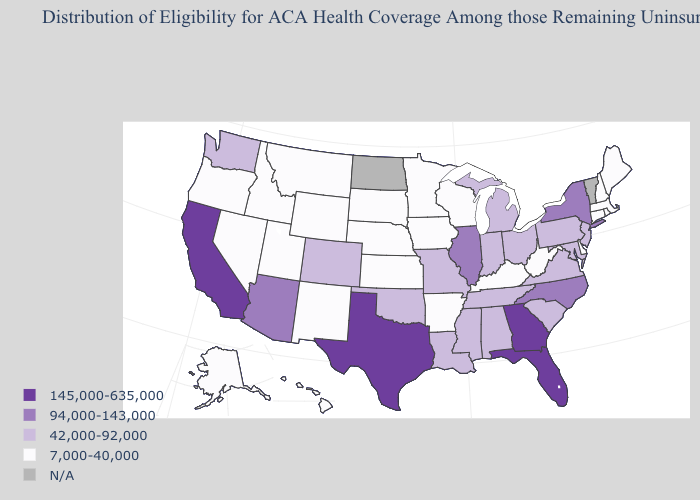What is the highest value in the USA?
Short answer required. 145,000-635,000. What is the highest value in the USA?
Keep it brief. 145,000-635,000. Name the states that have a value in the range 94,000-143,000?
Quick response, please. Arizona, Illinois, New York, North Carolina. Name the states that have a value in the range N/A?
Short answer required. North Dakota, Vermont. Does the first symbol in the legend represent the smallest category?
Be succinct. No. Does the map have missing data?
Keep it brief. Yes. What is the value of Oklahoma?
Be succinct. 42,000-92,000. Among the states that border West Virginia , does Maryland have the lowest value?
Be succinct. No. What is the value of Kansas?
Quick response, please. 7,000-40,000. What is the value of Missouri?
Give a very brief answer. 42,000-92,000. What is the lowest value in the USA?
Give a very brief answer. 7,000-40,000. Name the states that have a value in the range 94,000-143,000?
Keep it brief. Arizona, Illinois, New York, North Carolina. Does Florida have the highest value in the USA?
Short answer required. Yes. Name the states that have a value in the range N/A?
Give a very brief answer. North Dakota, Vermont. What is the highest value in states that border Texas?
Concise answer only. 42,000-92,000. 